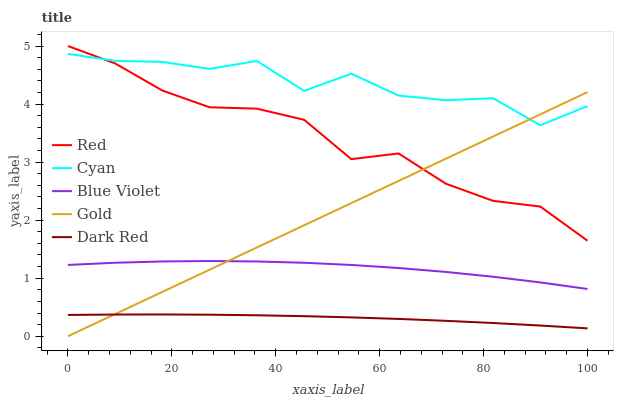Does Gold have the minimum area under the curve?
Answer yes or no. No. Does Gold have the maximum area under the curve?
Answer yes or no. No. Is Blue Violet the smoothest?
Answer yes or no. No. Is Blue Violet the roughest?
Answer yes or no. No. Does Blue Violet have the lowest value?
Answer yes or no. No. Does Gold have the highest value?
Answer yes or no. No. Is Dark Red less than Blue Violet?
Answer yes or no. Yes. Is Red greater than Blue Violet?
Answer yes or no. Yes. Does Dark Red intersect Blue Violet?
Answer yes or no. No. 